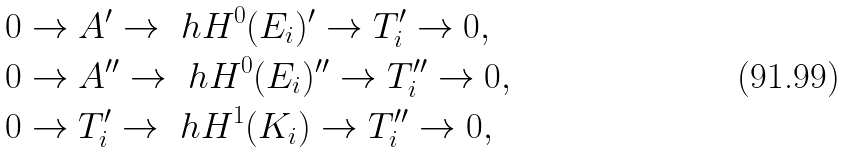<formula> <loc_0><loc_0><loc_500><loc_500>& 0 \to A ^ { \prime } \to \ h H ^ { 0 } ( E _ { i } ) ^ { \prime } \to T _ { i } ^ { \prime } \to 0 , \\ & 0 \to A ^ { \prime \prime } \to \ h H ^ { 0 } ( E _ { i } ) ^ { \prime \prime } \to T _ { i } ^ { \prime \prime } \to 0 , \\ & 0 \to T _ { i } ^ { \prime } \to \ h H ^ { 1 } ( K _ { i } ) \to T _ { i } ^ { \prime \prime } \to 0 ,</formula> 